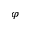Convert formula to latex. <formula><loc_0><loc_0><loc_500><loc_500>\varphi</formula> 